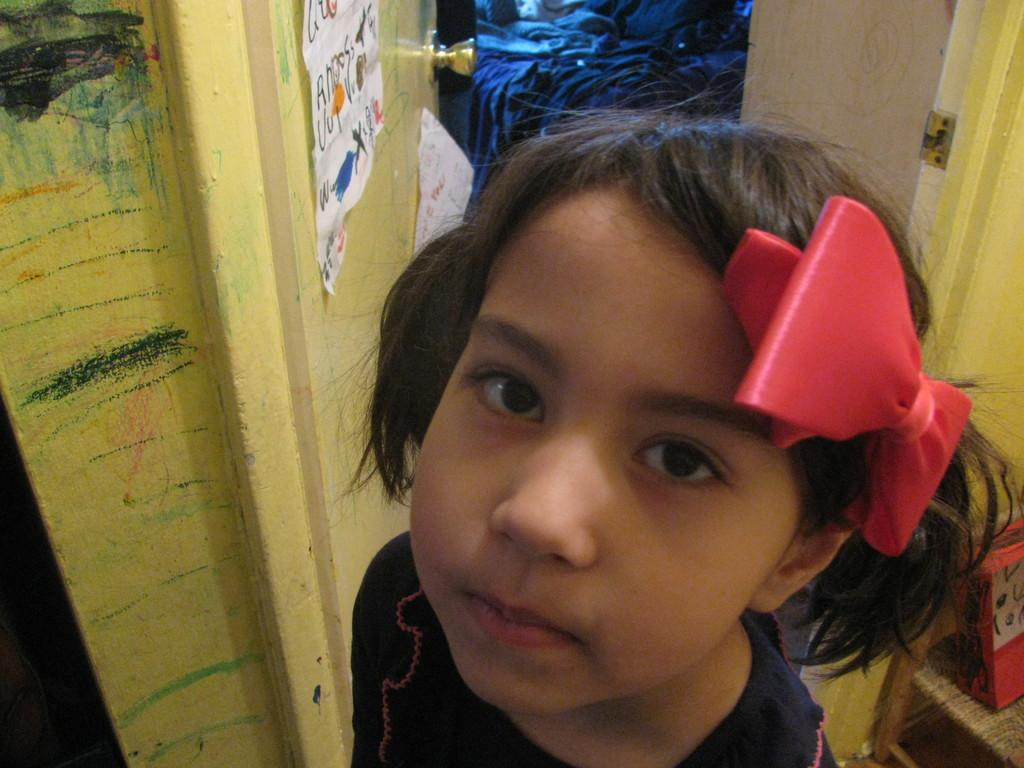Who is the main subject in the image? There is a girl in the image. What is the girl wearing? The girl is wearing a black top. What accessory is the girl wearing on her head? The girl has a red-colored clip on her head. What can be seen beside the girl in the image? There is a door beside the girl. What else is visible in the image besides the girl and the door? There is a bed with clothes on it in the image. What question is the girl asking in the image? There is no indication in the image that the girl is asking a question. 